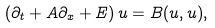<formula> <loc_0><loc_0><loc_500><loc_500>\left ( \partial _ { t } + A \partial _ { x } + E \right ) u = B ( u , u ) ,</formula> 